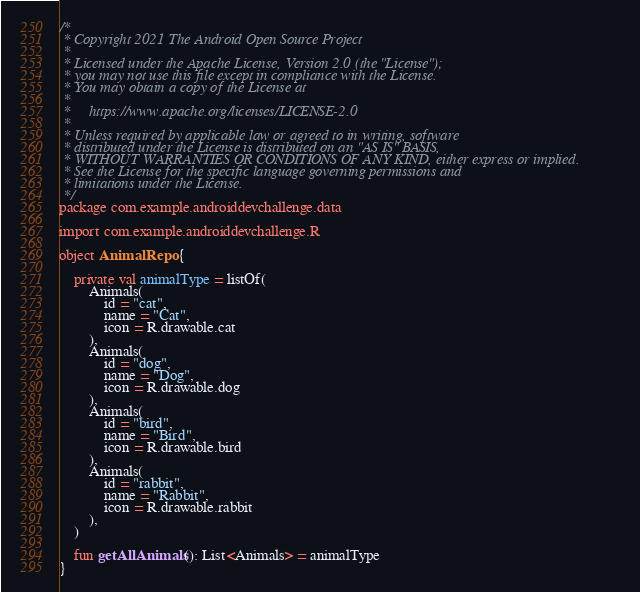Convert code to text. <code><loc_0><loc_0><loc_500><loc_500><_Kotlin_>/*
 * Copyright 2021 The Android Open Source Project
 *
 * Licensed under the Apache License, Version 2.0 (the "License");
 * you may not use this file except in compliance with the License.
 * You may obtain a copy of the License at
 *
 *     https://www.apache.org/licenses/LICENSE-2.0
 *
 * Unless required by applicable law or agreed to in writing, software
 * distributed under the License is distributed on an "AS IS" BASIS,
 * WITHOUT WARRANTIES OR CONDITIONS OF ANY KIND, either express or implied.
 * See the License for the specific language governing permissions and
 * limitations under the License.
 */
package com.example.androiddevchallenge.data

import com.example.androiddevchallenge.R

object AnimalRepo {

    private val animalType = listOf(
        Animals(
            id = "cat",
            name = "Cat",
            icon = R.drawable.cat
        ),
        Animals(
            id = "dog",
            name = "Dog",
            icon = R.drawable.dog
        ),
        Animals(
            id = "bird",
            name = "Bird",
            icon = R.drawable.bird
        ),
        Animals(
            id = "rabbit",
            name = "Rabbit",
            icon = R.drawable.rabbit
        ),
    )

    fun getAllAnimals(): List<Animals> = animalType
}
</code> 